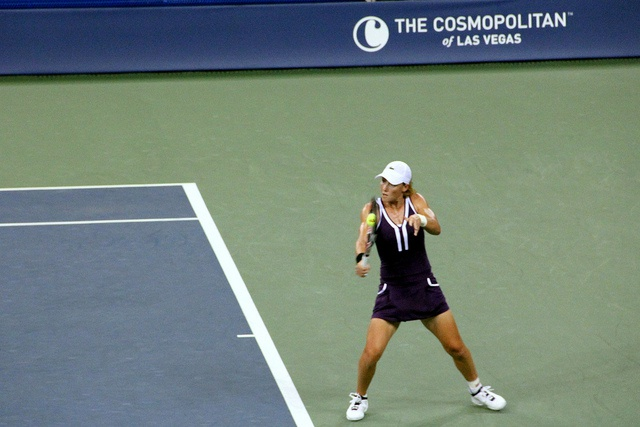Describe the objects in this image and their specific colors. I can see people in navy, black, white, brown, and olive tones, tennis racket in navy, gray, black, darkgray, and darkgreen tones, and sports ball in navy, khaki, and darkgreen tones in this image. 